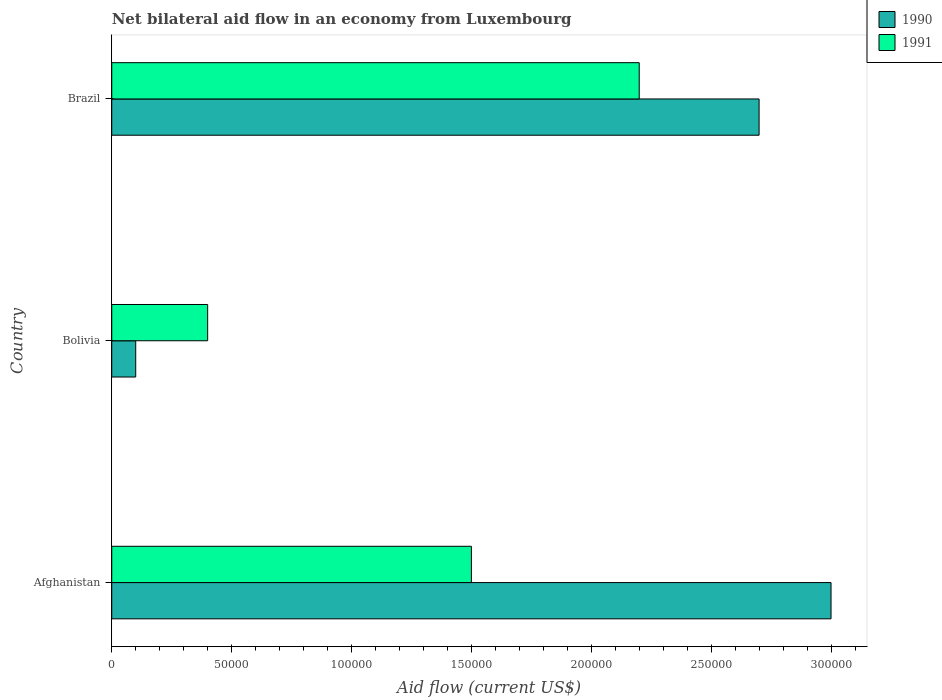How many groups of bars are there?
Make the answer very short. 3. How many bars are there on the 2nd tick from the bottom?
Ensure brevity in your answer.  2. What is the label of the 3rd group of bars from the top?
Provide a succinct answer. Afghanistan. In how many cases, is the number of bars for a given country not equal to the number of legend labels?
Provide a short and direct response. 0. What is the net bilateral aid flow in 1991 in Brazil?
Your response must be concise. 2.20e+05. Across all countries, what is the maximum net bilateral aid flow in 1991?
Give a very brief answer. 2.20e+05. In which country was the net bilateral aid flow in 1991 maximum?
Provide a succinct answer. Brazil. In which country was the net bilateral aid flow in 1990 minimum?
Ensure brevity in your answer.  Bolivia. What is the total net bilateral aid flow in 1990 in the graph?
Your answer should be very brief. 5.80e+05. What is the difference between the net bilateral aid flow in 1990 in Afghanistan and that in Brazil?
Provide a short and direct response. 3.00e+04. What is the difference between the net bilateral aid flow in 1990 in Brazil and the net bilateral aid flow in 1991 in Bolivia?
Provide a short and direct response. 2.30e+05. What is the average net bilateral aid flow in 1991 per country?
Provide a short and direct response. 1.37e+05. What is the difference between the net bilateral aid flow in 1990 and net bilateral aid flow in 1991 in Bolivia?
Your response must be concise. -3.00e+04. In how many countries, is the net bilateral aid flow in 1990 greater than 120000 US$?
Provide a succinct answer. 2. What is the ratio of the net bilateral aid flow in 1991 in Afghanistan to that in Brazil?
Offer a very short reply. 0.68. Is the net bilateral aid flow in 1991 in Afghanistan less than that in Bolivia?
Keep it short and to the point. No. Is the difference between the net bilateral aid flow in 1990 in Bolivia and Brazil greater than the difference between the net bilateral aid flow in 1991 in Bolivia and Brazil?
Keep it short and to the point. No. What is the difference between the highest and the second highest net bilateral aid flow in 1990?
Your answer should be very brief. 3.00e+04. In how many countries, is the net bilateral aid flow in 1990 greater than the average net bilateral aid flow in 1990 taken over all countries?
Offer a terse response. 2. What does the 1st bar from the top in Brazil represents?
Provide a succinct answer. 1991. What does the 1st bar from the bottom in Brazil represents?
Offer a terse response. 1990. How many countries are there in the graph?
Give a very brief answer. 3. Are the values on the major ticks of X-axis written in scientific E-notation?
Provide a succinct answer. No. Where does the legend appear in the graph?
Ensure brevity in your answer.  Top right. How many legend labels are there?
Your response must be concise. 2. What is the title of the graph?
Your answer should be compact. Net bilateral aid flow in an economy from Luxembourg. Does "2008" appear as one of the legend labels in the graph?
Offer a terse response. No. What is the Aid flow (current US$) of 1991 in Afghanistan?
Give a very brief answer. 1.50e+05. What is the Aid flow (current US$) in 1990 in Bolivia?
Ensure brevity in your answer.  10000. What is the Aid flow (current US$) of 1990 in Brazil?
Your response must be concise. 2.70e+05. Across all countries, what is the minimum Aid flow (current US$) in 1991?
Offer a terse response. 4.00e+04. What is the total Aid flow (current US$) of 1990 in the graph?
Offer a terse response. 5.80e+05. What is the difference between the Aid flow (current US$) of 1990 in Afghanistan and that in Bolivia?
Provide a succinct answer. 2.90e+05. What is the difference between the Aid flow (current US$) of 1990 in Afghanistan and that in Brazil?
Keep it short and to the point. 3.00e+04. What is the difference between the Aid flow (current US$) in 1991 in Afghanistan and that in Brazil?
Offer a terse response. -7.00e+04. What is the difference between the Aid flow (current US$) of 1990 in Bolivia and the Aid flow (current US$) of 1991 in Brazil?
Your answer should be compact. -2.10e+05. What is the average Aid flow (current US$) in 1990 per country?
Provide a succinct answer. 1.93e+05. What is the average Aid flow (current US$) in 1991 per country?
Your answer should be compact. 1.37e+05. What is the difference between the Aid flow (current US$) in 1990 and Aid flow (current US$) in 1991 in Afghanistan?
Provide a short and direct response. 1.50e+05. What is the ratio of the Aid flow (current US$) of 1990 in Afghanistan to that in Bolivia?
Make the answer very short. 30. What is the ratio of the Aid flow (current US$) in 1991 in Afghanistan to that in Bolivia?
Ensure brevity in your answer.  3.75. What is the ratio of the Aid flow (current US$) in 1990 in Afghanistan to that in Brazil?
Your answer should be compact. 1.11. What is the ratio of the Aid flow (current US$) of 1991 in Afghanistan to that in Brazil?
Keep it short and to the point. 0.68. What is the ratio of the Aid flow (current US$) in 1990 in Bolivia to that in Brazil?
Your answer should be very brief. 0.04. What is the ratio of the Aid flow (current US$) of 1991 in Bolivia to that in Brazil?
Make the answer very short. 0.18. What is the difference between the highest and the lowest Aid flow (current US$) in 1990?
Offer a terse response. 2.90e+05. 